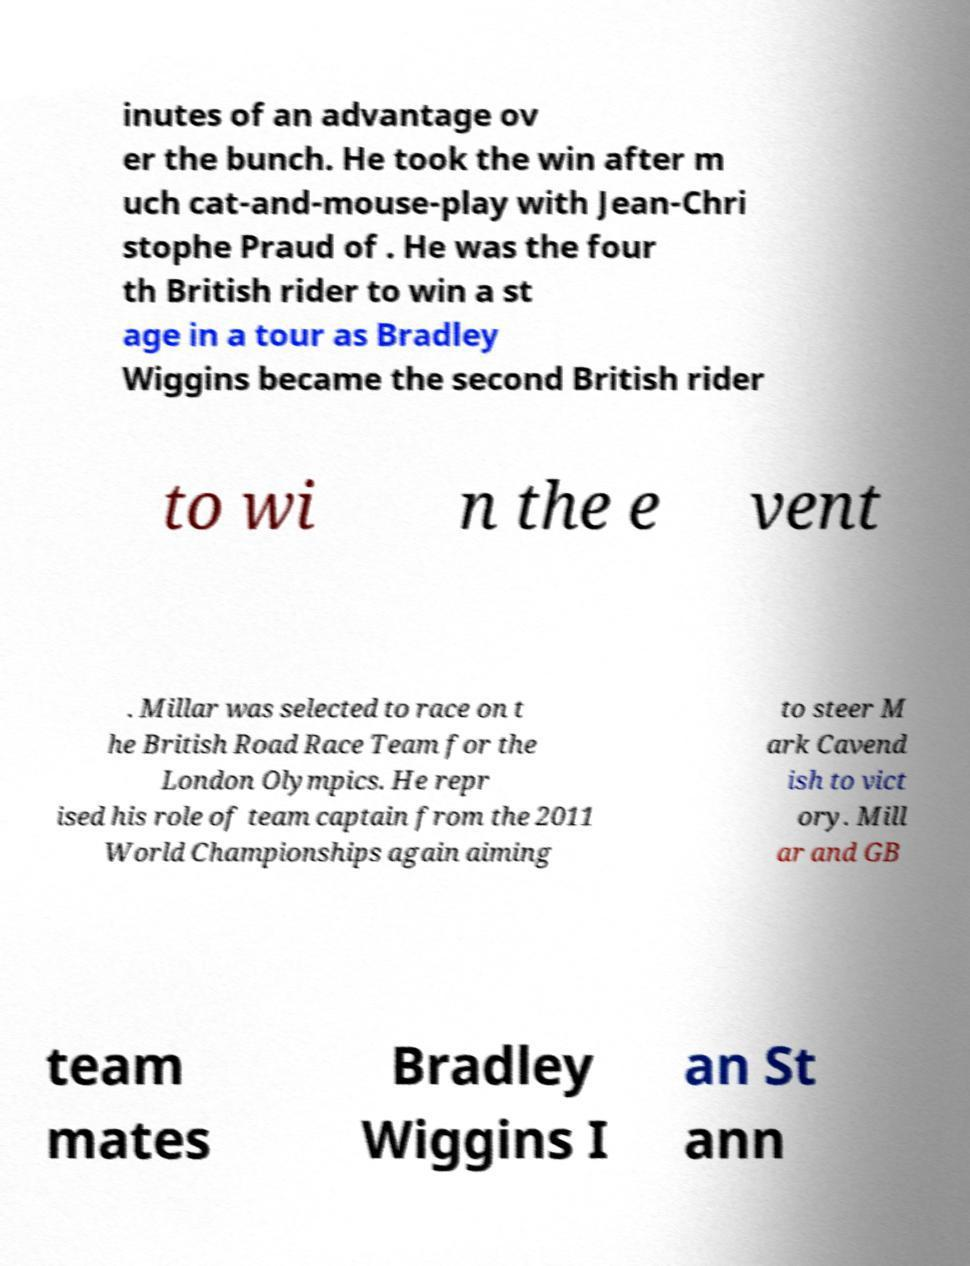What messages or text are displayed in this image? I need them in a readable, typed format. inutes of an advantage ov er the bunch. He took the win after m uch cat-and-mouse-play with Jean-Chri stophe Praud of . He was the four th British rider to win a st age in a tour as Bradley Wiggins became the second British rider to wi n the e vent . Millar was selected to race on t he British Road Race Team for the London Olympics. He repr ised his role of team captain from the 2011 World Championships again aiming to steer M ark Cavend ish to vict ory. Mill ar and GB team mates Bradley Wiggins I an St ann 